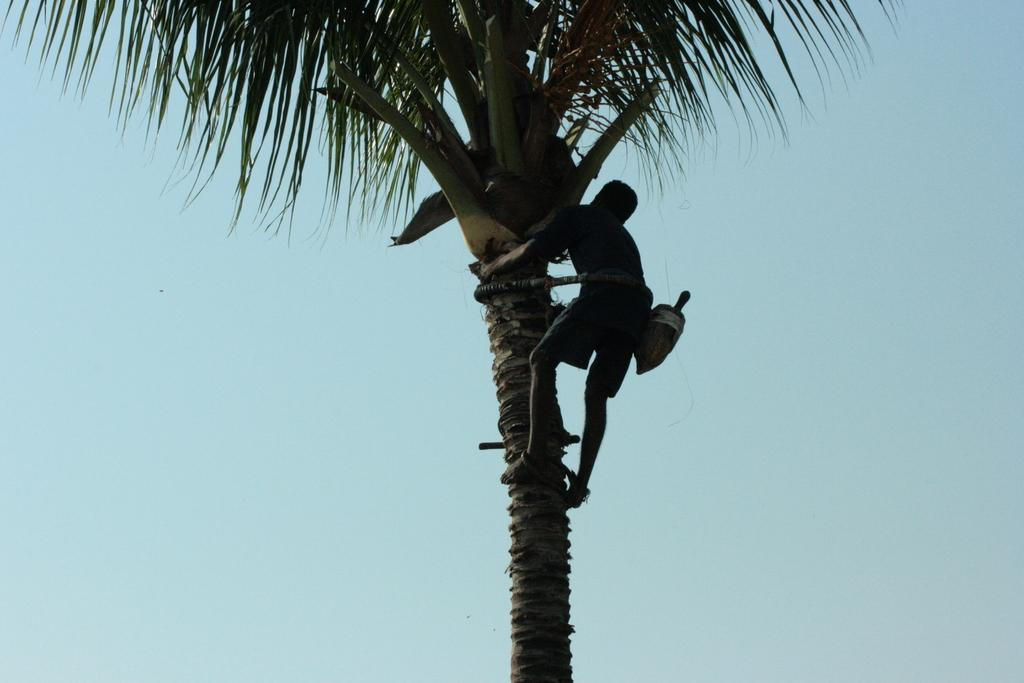What is the main activity being performed in the image? There is a person climbing a coconut tree in the image. What can be seen in the background of the image? The sky is visible in the background of the image. What type of mailbox can be seen at the top of the coconut tree in the image? There is no mailbox present in the image; it features a person climbing a coconut tree. How does the wind blow the sign in the image? There is no sign present in the image, so it cannot be determined how the wind would affect it. 